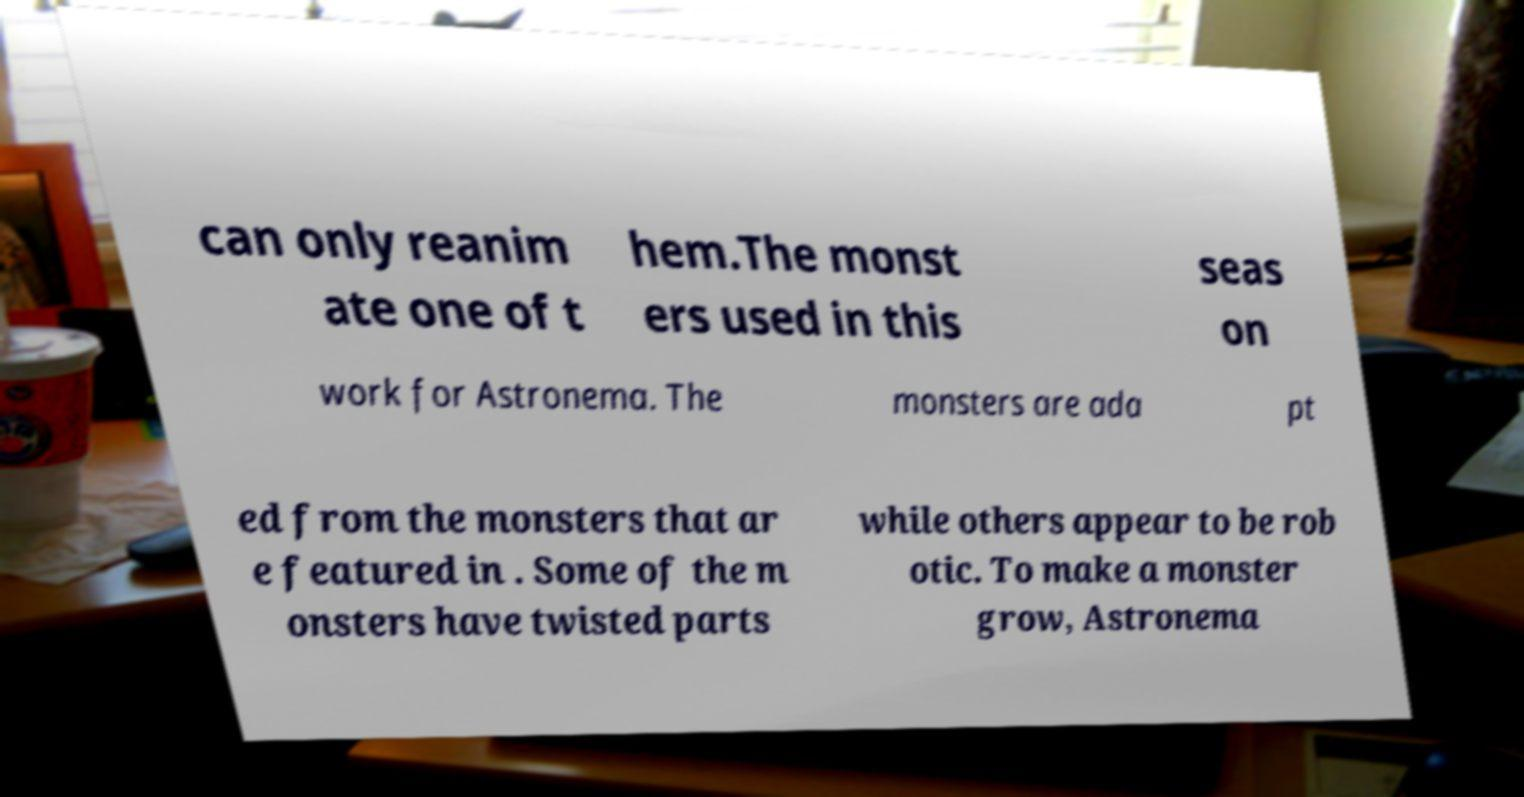Please read and relay the text visible in this image. What does it say? can only reanim ate one of t hem.The monst ers used in this seas on work for Astronema. The monsters are ada pt ed from the monsters that ar e featured in . Some of the m onsters have twisted parts while others appear to be rob otic. To make a monster grow, Astronema 